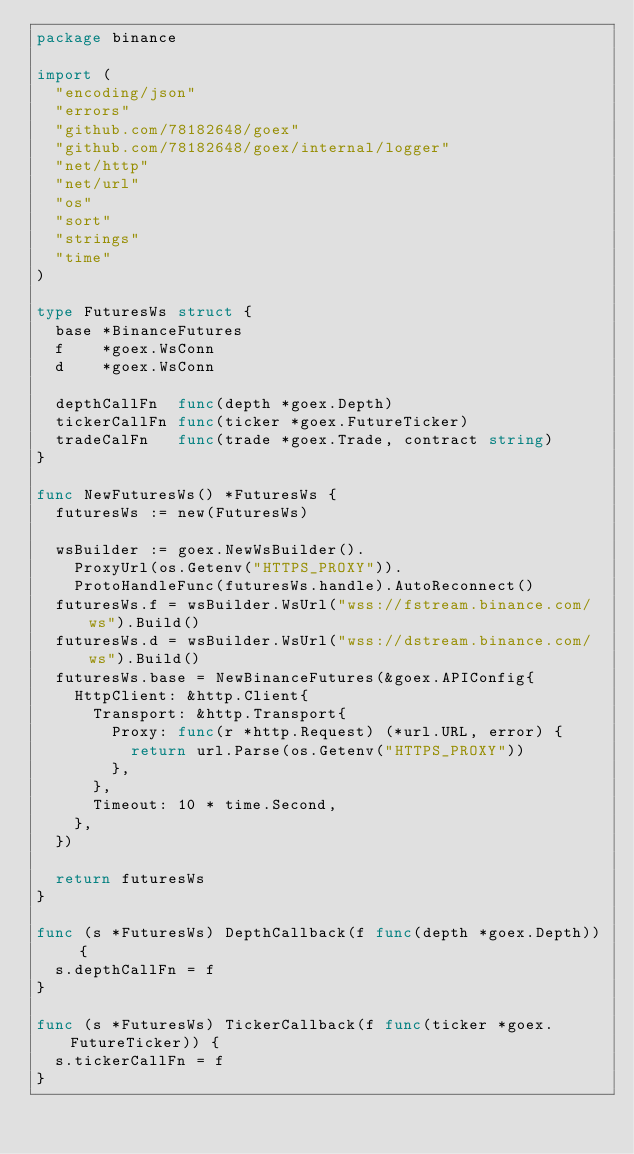Convert code to text. <code><loc_0><loc_0><loc_500><loc_500><_Go_>package binance

import (
	"encoding/json"
	"errors"
	"github.com/78182648/goex"
	"github.com/78182648/goex/internal/logger"
	"net/http"
	"net/url"
	"os"
	"sort"
	"strings"
	"time"
)

type FuturesWs struct {
	base *BinanceFutures
	f    *goex.WsConn
	d    *goex.WsConn

	depthCallFn  func(depth *goex.Depth)
	tickerCallFn func(ticker *goex.FutureTicker)
	tradeCalFn   func(trade *goex.Trade, contract string)
}

func NewFuturesWs() *FuturesWs {
	futuresWs := new(FuturesWs)

	wsBuilder := goex.NewWsBuilder().
		ProxyUrl(os.Getenv("HTTPS_PROXY")).
		ProtoHandleFunc(futuresWs.handle).AutoReconnect()
	futuresWs.f = wsBuilder.WsUrl("wss://fstream.binance.com/ws").Build()
	futuresWs.d = wsBuilder.WsUrl("wss://dstream.binance.com/ws").Build()
	futuresWs.base = NewBinanceFutures(&goex.APIConfig{
		HttpClient: &http.Client{
			Transport: &http.Transport{
				Proxy: func(r *http.Request) (*url.URL, error) {
					return url.Parse(os.Getenv("HTTPS_PROXY"))
				},
			},
			Timeout: 10 * time.Second,
		},
	})

	return futuresWs
}

func (s *FuturesWs) DepthCallback(f func(depth *goex.Depth)) {
	s.depthCallFn = f
}

func (s *FuturesWs) TickerCallback(f func(ticker *goex.FutureTicker)) {
	s.tickerCallFn = f
}
</code> 